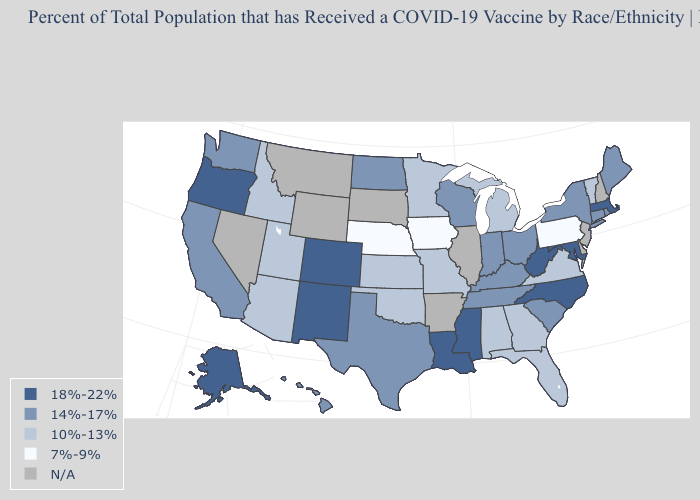Name the states that have a value in the range N/A?
Give a very brief answer. Arkansas, Delaware, Illinois, Montana, Nevada, New Hampshire, New Jersey, South Dakota, Wyoming. What is the highest value in the USA?
Write a very short answer. 18%-22%. Among the states that border Indiana , which have the highest value?
Quick response, please. Kentucky, Ohio. Is the legend a continuous bar?
Quick response, please. No. What is the lowest value in the South?
Be succinct. 10%-13%. Among the states that border North Carolina , does South Carolina have the highest value?
Be succinct. Yes. What is the highest value in states that border Indiana?
Keep it brief. 14%-17%. What is the value of Missouri?
Short answer required. 10%-13%. Which states hav the highest value in the Northeast?
Short answer required. Massachusetts. Name the states that have a value in the range 14%-17%?
Answer briefly. California, Connecticut, Hawaii, Indiana, Kentucky, Maine, New York, North Dakota, Ohio, Rhode Island, South Carolina, Tennessee, Texas, Washington, Wisconsin. Which states have the lowest value in the USA?
Keep it brief. Iowa, Nebraska, Pennsylvania. Name the states that have a value in the range 14%-17%?
Answer briefly. California, Connecticut, Hawaii, Indiana, Kentucky, Maine, New York, North Dakota, Ohio, Rhode Island, South Carolina, Tennessee, Texas, Washington, Wisconsin. 